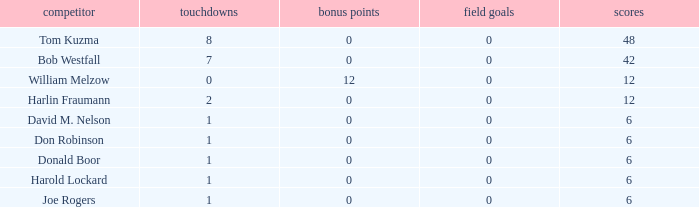Name the points for donald boor 6.0. 